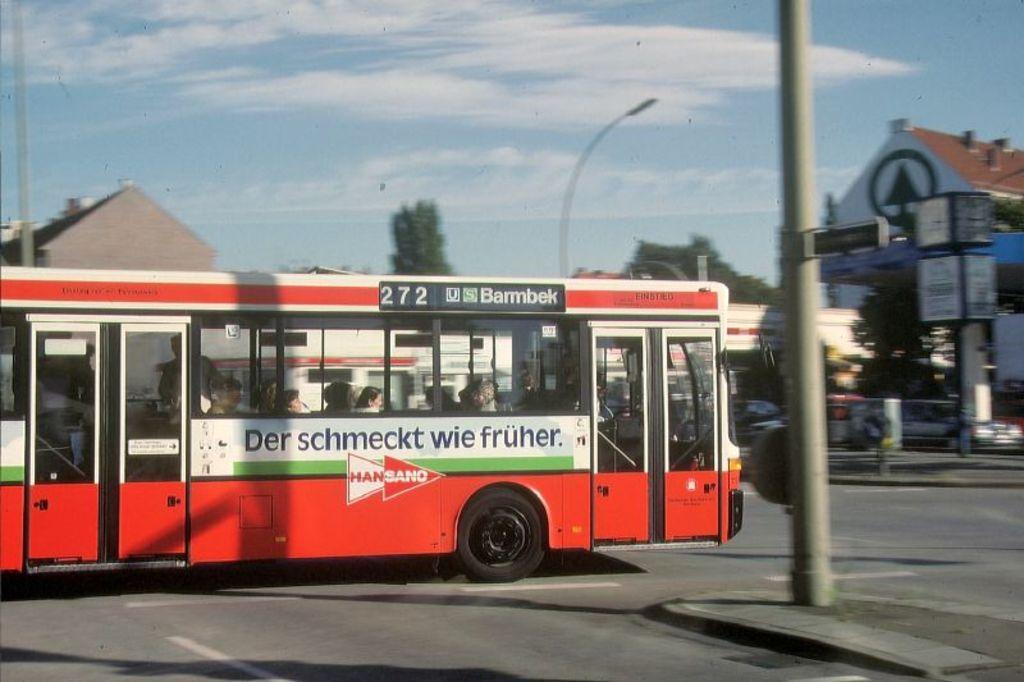Describe this image in one or two sentences. In the foreground of this image, there is a bus moving on the road. On the right, there is a pole. In the background, there are few buildings, poles, trees, few vehicles, sky and the cloud. 